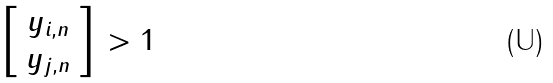Convert formula to latex. <formula><loc_0><loc_0><loc_500><loc_500>\| \left [ \begin{array} { c } y _ { i , n } \\ y _ { j , n } \end{array} \right ] \| > 1</formula> 